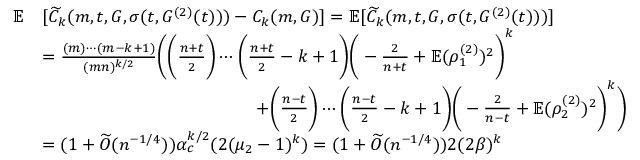Convert formula to latex. <formula><loc_0><loc_0><loc_500><loc_500>\begin{array} { r l } { \mathbb { E } } & { [ \widetilde { C } _ { k } ( m , t , G , \sigma ( t , G ^ { ( 2 ) } ( t ) ) ) - C _ { k } ( m , G ) ] = \mathbb { E } [ \widetilde { C } _ { k } ( m , t , G , \sigma ( t , G ^ { ( 2 ) } ( t ) ) ) ] } \\ & { = \frac { ( m ) \cdots ( m - k + 1 ) } { ( m n ) ^ { k / 2 } } \left ( \left ( \frac { n + t } { 2 } \right ) \cdots \left ( \frac { n + t } { 2 } - k + 1 \right ) \left ( - \frac { 2 } { n + t } + \mathbb { E } ( \rho _ { 1 } ^ { ( 2 ) } ) ^ { 2 } \right ) ^ { k } } \\ & { \quad + \left ( \frac { n - t } { 2 } \right ) \cdots \left ( \frac { n - t } { 2 } - k + 1 \right ) \left ( - \frac { 2 } { n - t } + \mathbb { E } ( \rho _ { 2 } ^ { ( 2 ) } ) ^ { 2 } \right ) ^ { k } \right ) } \\ & { = ( 1 + \widetilde { O } ( n ^ { - 1 / 4 } ) ) \alpha _ { c } ^ { k / 2 } ( 2 ( \mu _ { 2 } - 1 ) ^ { k } ) = ( 1 + \widetilde { O } ( n ^ { - 1 / 4 } ) ) 2 ( 2 \beta ) ^ { k } } \end{array}</formula> 